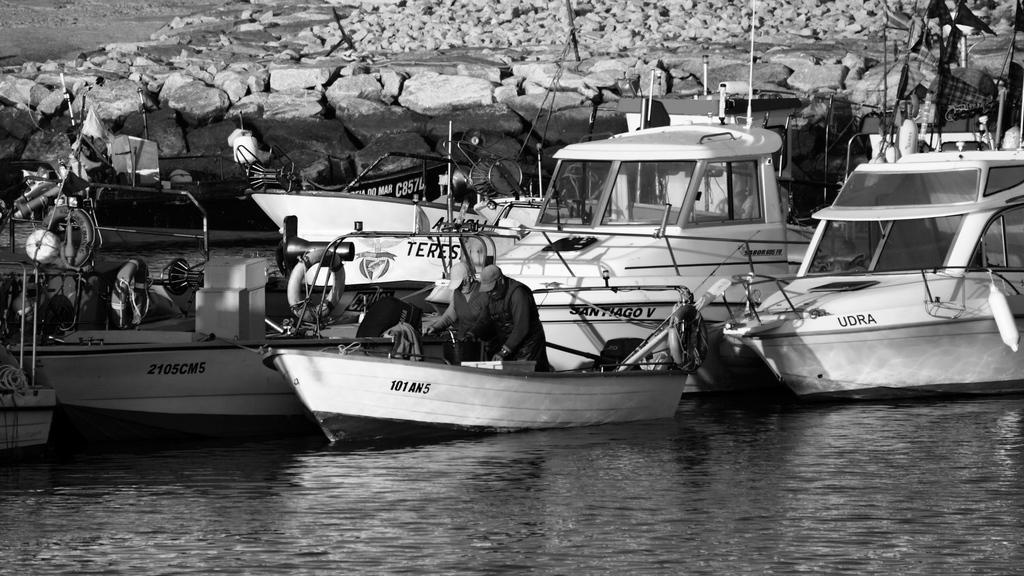<image>
Present a compact description of the photo's key features. Some boats on the water and one is named Teres. 